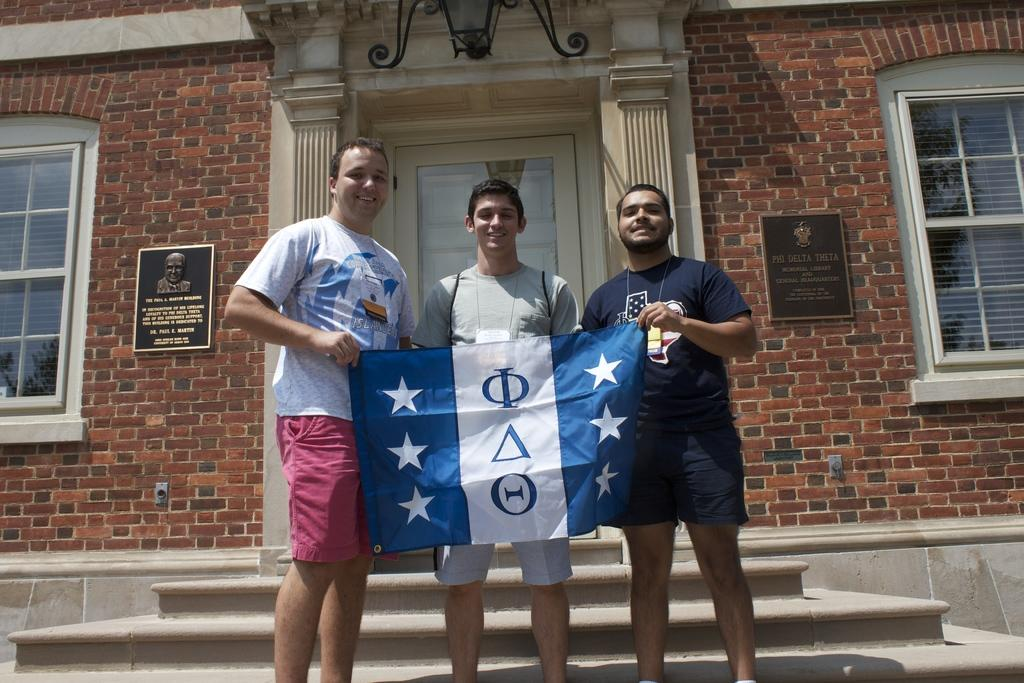How many people are present in the image? There are 3 people in the image. What are the people holding? The people are holding a flag. What can be seen behind the people? There are stairs behind the people. What is visible in the background of the image? There is a building in the background. Can you describe the building? The building has a door at the center and 2 windows. Are there any other objects visible inside the building? Yes, there is a lamp and 2 photo frames inside the building. Are there any fairies flying around the building in the image? There are no fairies visible in the image; it only shows 3 people holding a flag, stairs, and a building with a door, windows, a lamp, and 2 photo frames. 